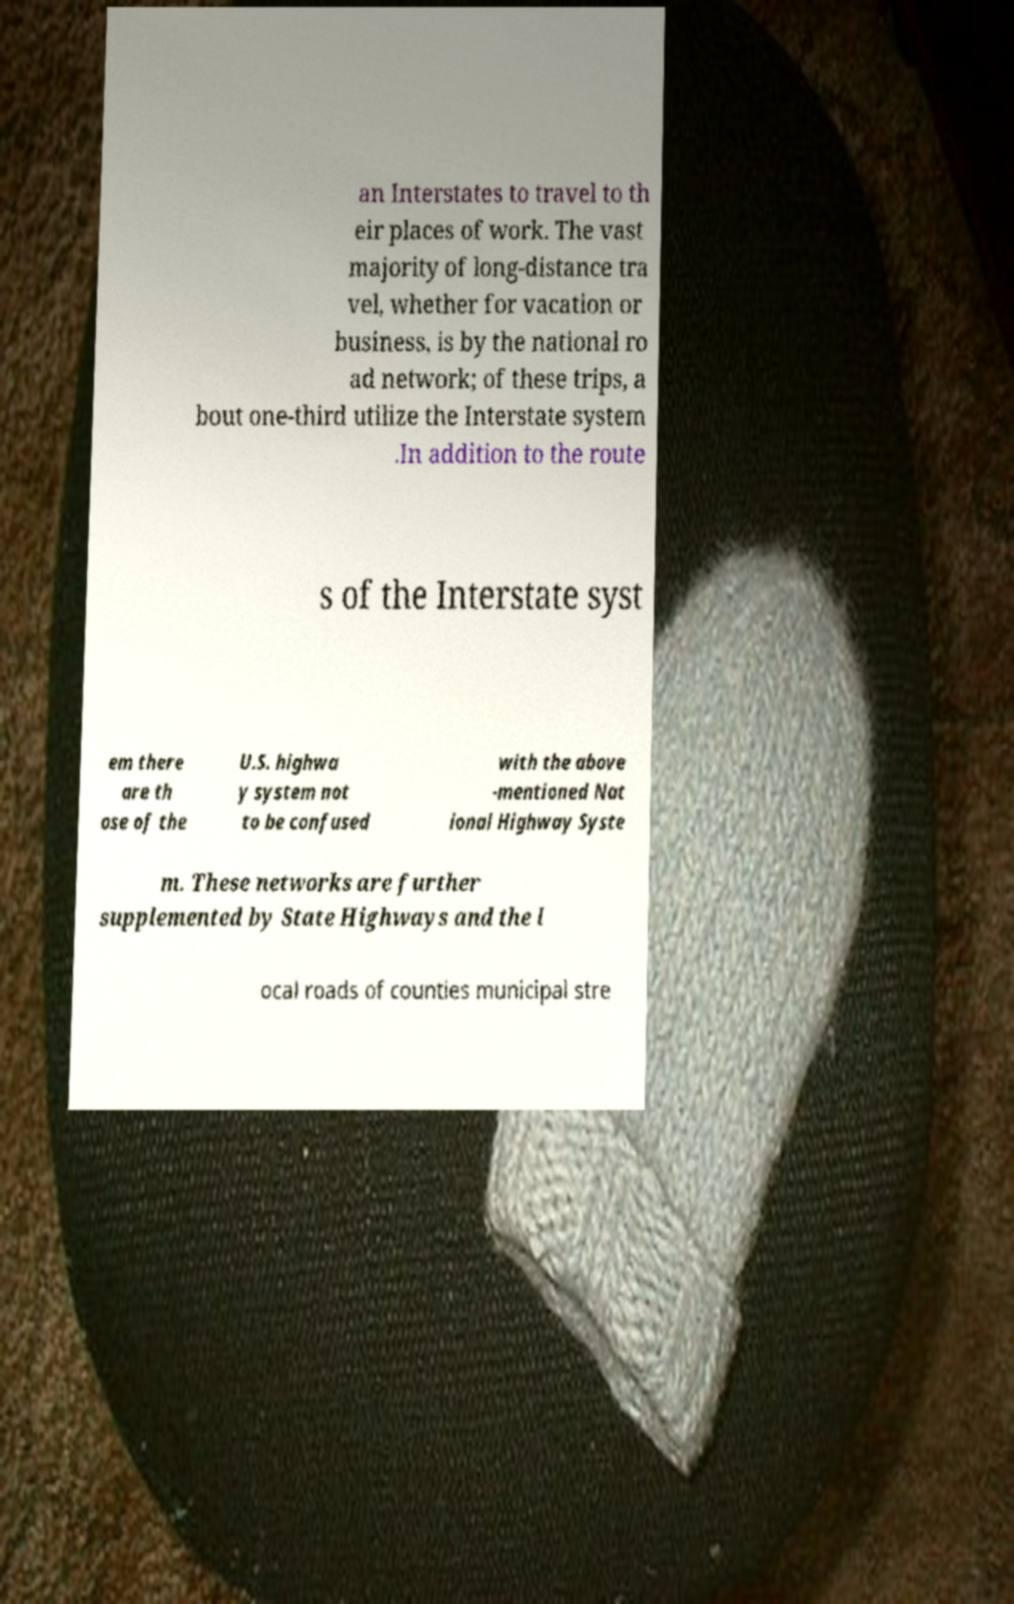I need the written content from this picture converted into text. Can you do that? an Interstates to travel to th eir places of work. The vast majority of long-distance tra vel, whether for vacation or business, is by the national ro ad network; of these trips, a bout one-third utilize the Interstate system .In addition to the route s of the Interstate syst em there are th ose of the U.S. highwa y system not to be confused with the above -mentioned Nat ional Highway Syste m. These networks are further supplemented by State Highways and the l ocal roads of counties municipal stre 